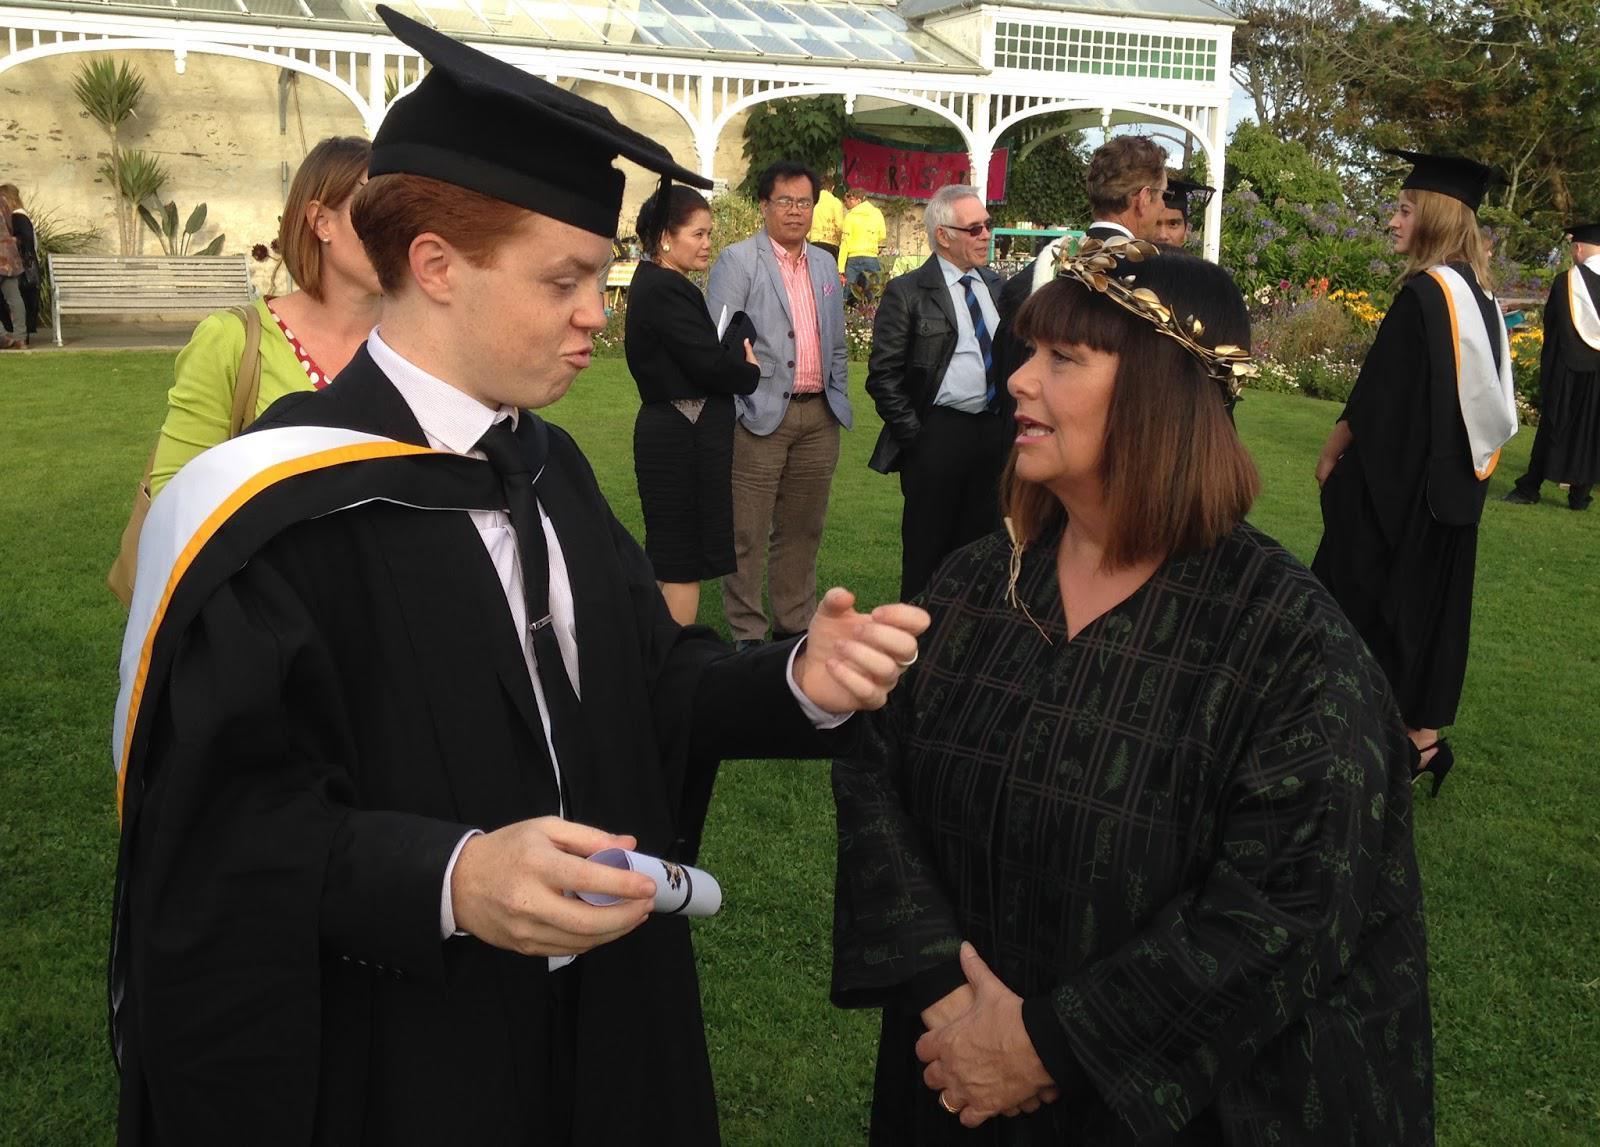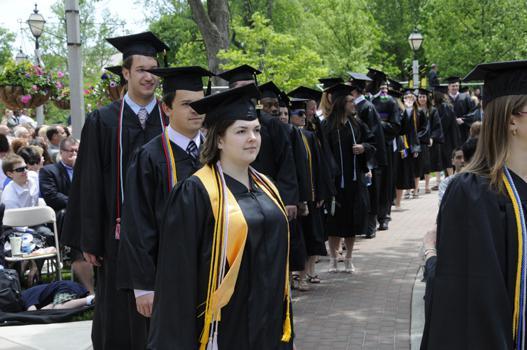The first image is the image on the left, the second image is the image on the right. Evaluate the accuracy of this statement regarding the images: "The left image contains only males, posed side-to-side facing forward, and at least one of them is a black man wearing a graduation cap.". Is it true? Answer yes or no. No. The first image is the image on the left, the second image is the image on the right. Evaluate the accuracy of this statement regarding the images: "The people in the image on the right are standing near trees.". Is it true? Answer yes or no. Yes. 